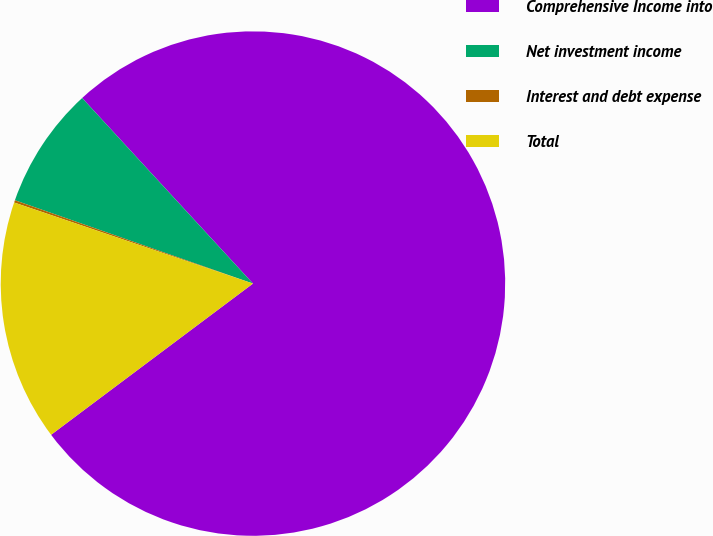Convert chart. <chart><loc_0><loc_0><loc_500><loc_500><pie_chart><fcel>Comprehensive Income into<fcel>Net investment income<fcel>Interest and debt expense<fcel>Total<nl><fcel>76.61%<fcel>7.8%<fcel>0.15%<fcel>15.44%<nl></chart> 